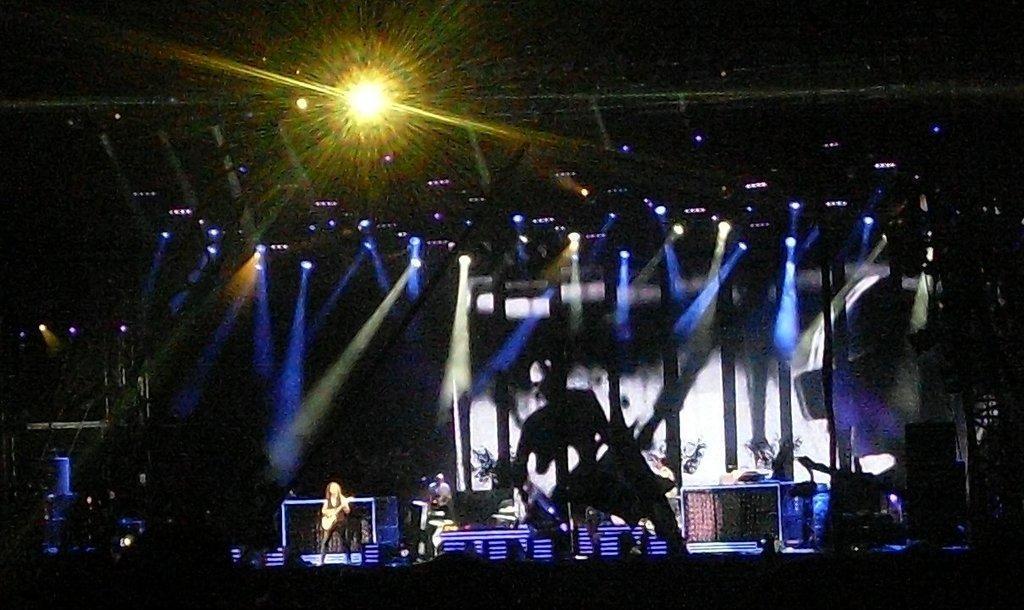Please provide a concise description of this image. This picture is dark. In the background of the image there are people, among them there is a person playing a guitar and we can see lights and objects. 